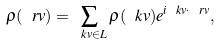Convert formula to latex. <formula><loc_0><loc_0><loc_500><loc_500>\rho ( \ r v ) = \sum _ { \ k v \in L } \rho ( \ k v ) e ^ { i \ k v \cdot \ r v } ,</formula> 